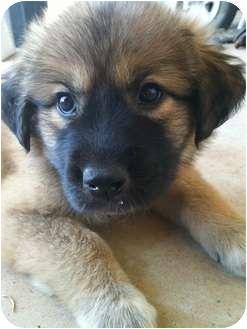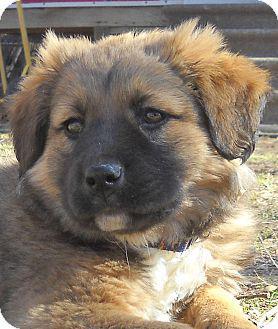The first image is the image on the left, the second image is the image on the right. Given the left and right images, does the statement "The dog in one of the images is lying down on the carpet." hold true? Answer yes or no. Yes. The first image is the image on the left, the second image is the image on the right. Considering the images on both sides, is "The dogs in the two images are looking in the same direction, and no dog has its tongue showing." valid? Answer yes or no. Yes. 